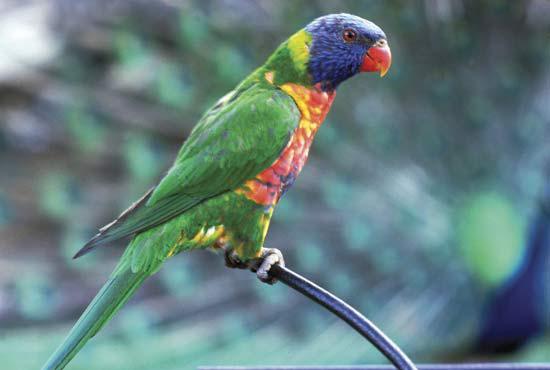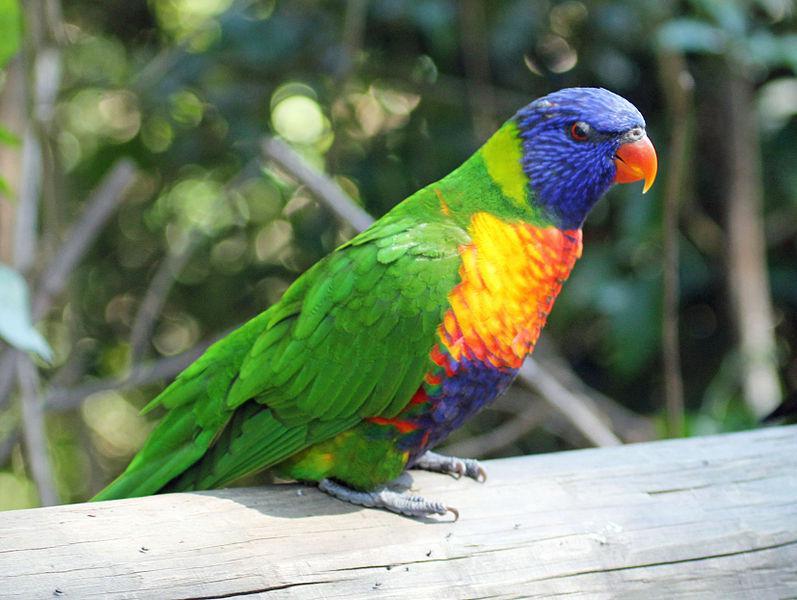The first image is the image on the left, the second image is the image on the right. Assess this claim about the two images: "Four colorful birds are perched outside.". Correct or not? Answer yes or no. No. The first image is the image on the left, the second image is the image on the right. For the images shown, is this caption "Left image contains three parrots, and right image contains one left-facing parrot." true? Answer yes or no. No. 